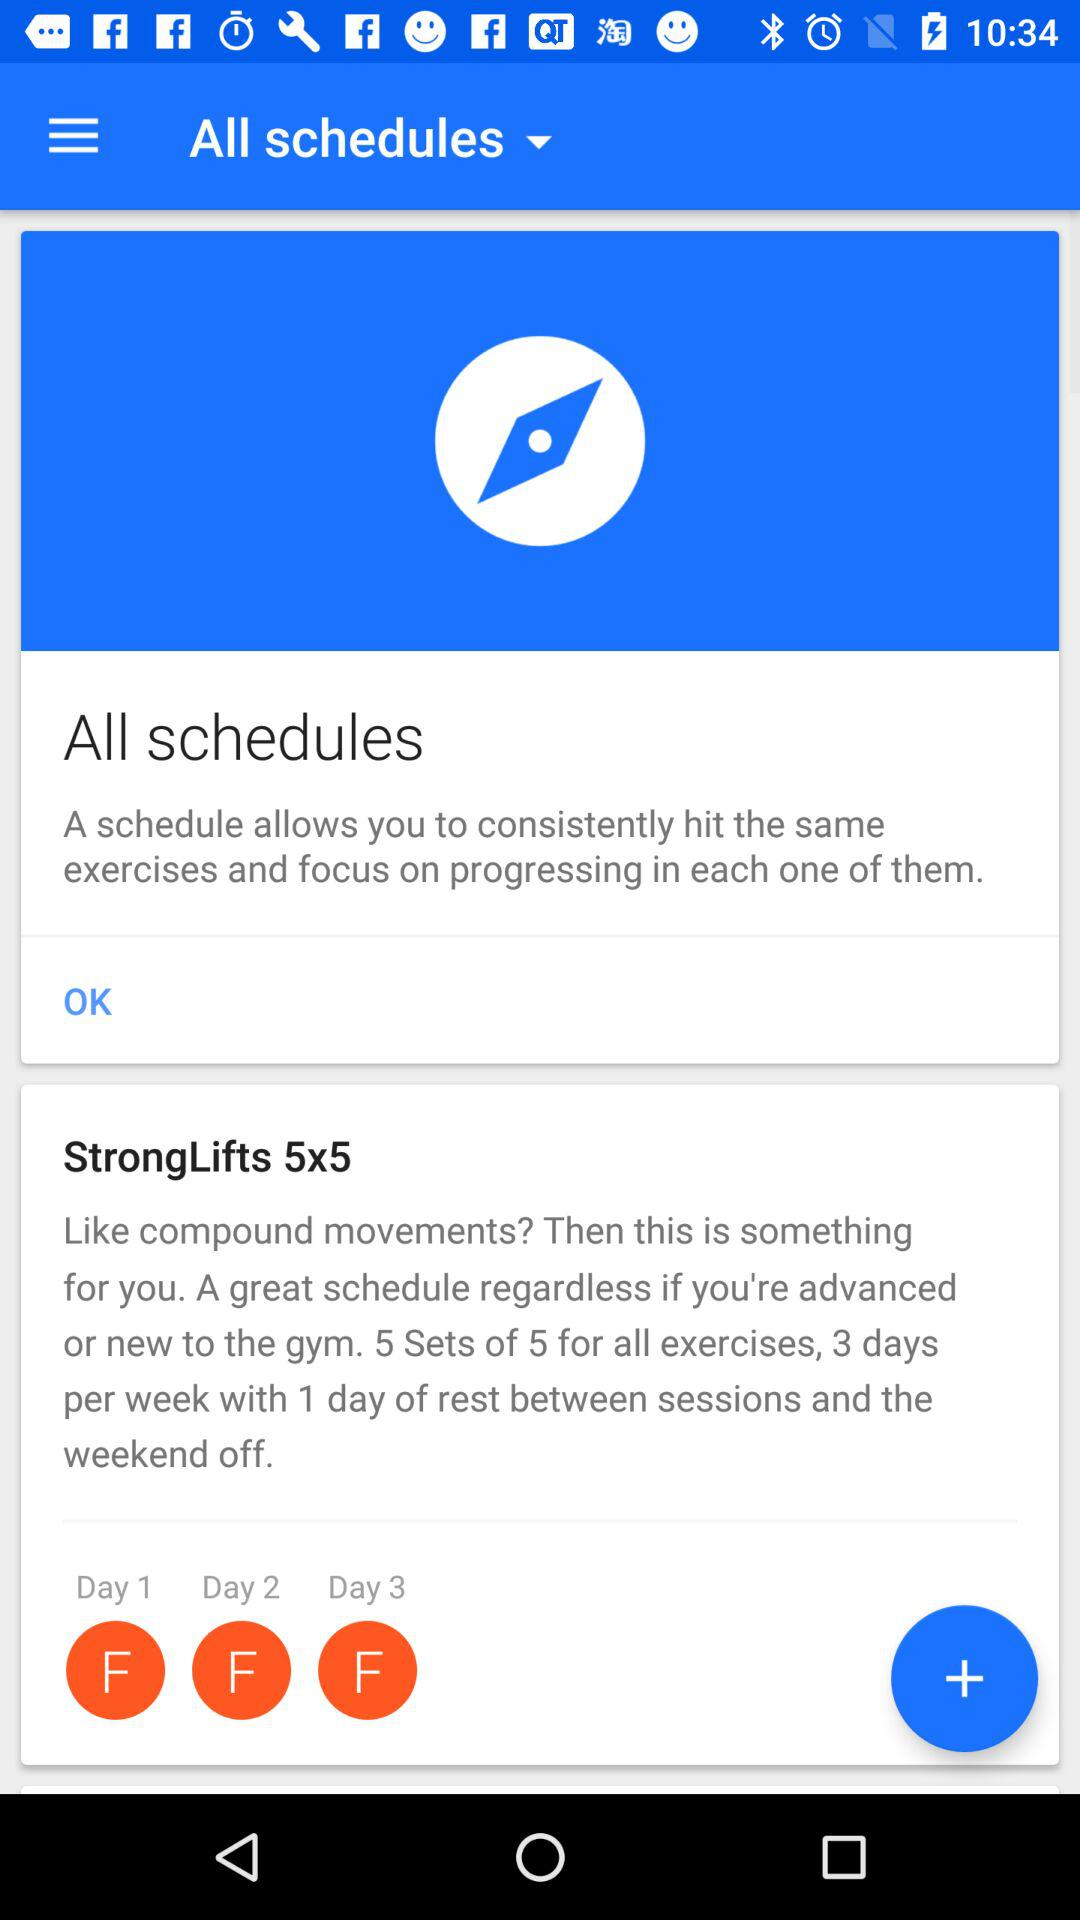How many days does the StrongLifts 5x5 schedule have?
Answer the question using a single word or phrase. 3 